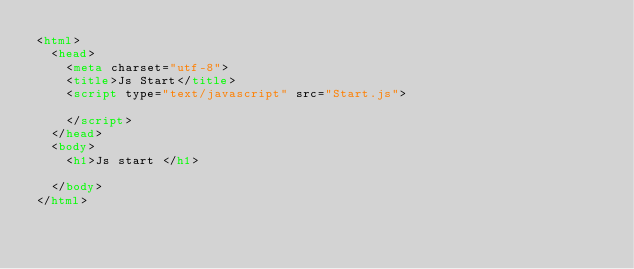<code> <loc_0><loc_0><loc_500><loc_500><_HTML_><html>
  <head>
    <meta charset="utf-8">
    <title>Js Start</title>
    <script type="text/javascript" src="Start.js">

    </script>
  </head>
  <body>
    <h1>Js start </h1>

  </body>
</html>
</code> 